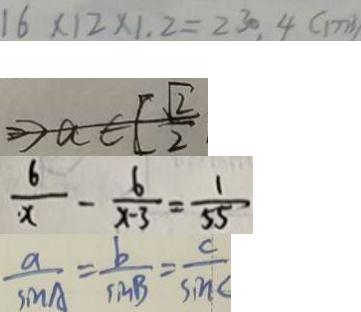<formula> <loc_0><loc_0><loc_500><loc_500>1 6 \times 1 2 \times 1 . 2 = 2 3 0 . 4 ( m ^ { 3 } ) 
 > a \in [ \frac { \sqrt { 2 } } { 2 } 
 \frac { 6 } { x } - \frac { 6 } { x - 3 } = \frac { 1 } { 5 5 } 
 \frac { a } { \sin A } = \frac { b } { \sin B } = \frac { c } { \sin C }</formula> 